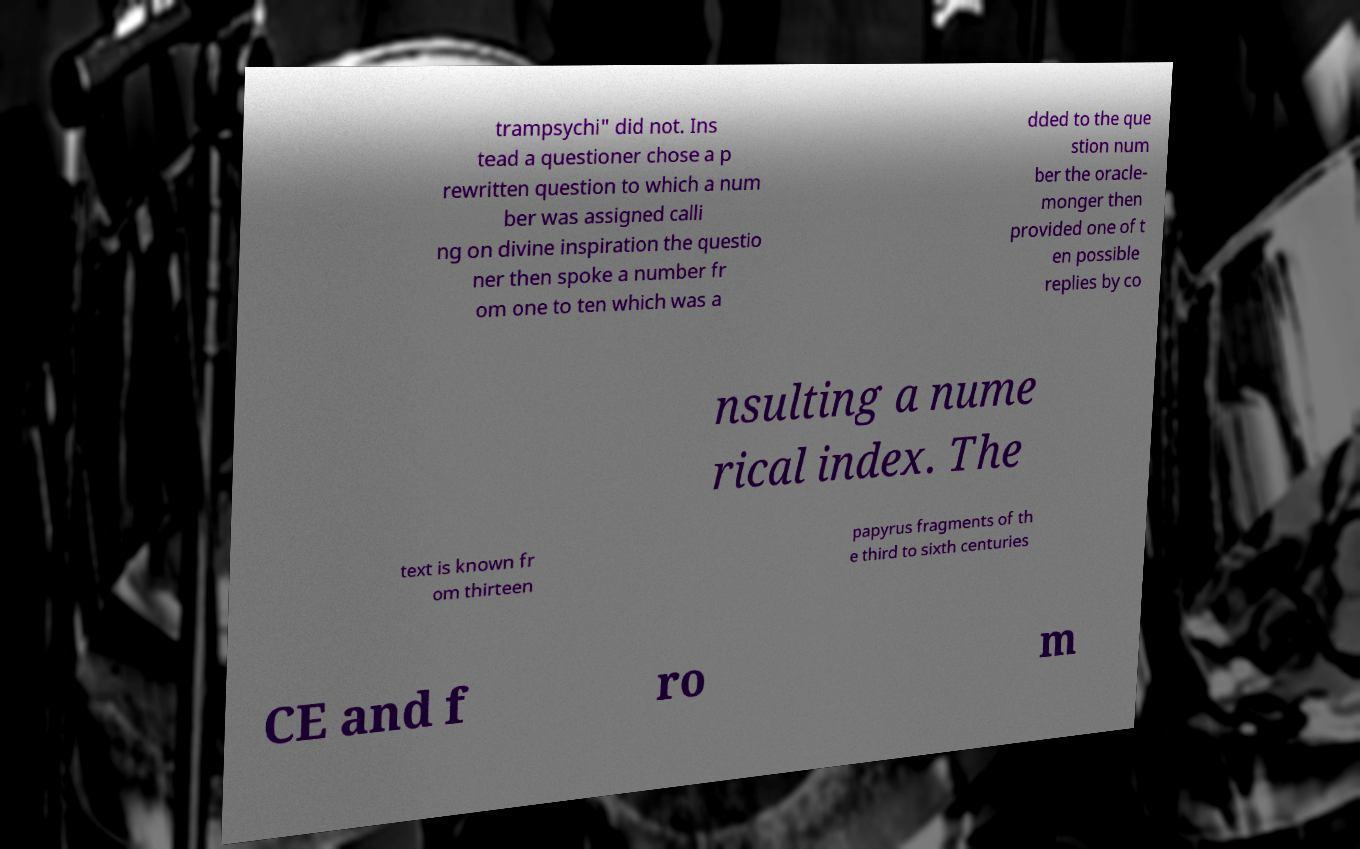Can you read and provide the text displayed in the image?This photo seems to have some interesting text. Can you extract and type it out for me? trampsychi" did not. Ins tead a questioner chose a p rewritten question to which a num ber was assigned calli ng on divine inspiration the questio ner then spoke a number fr om one to ten which was a dded to the que stion num ber the oracle- monger then provided one of t en possible replies by co nsulting a nume rical index. The text is known fr om thirteen papyrus fragments of th e third to sixth centuries CE and f ro m 